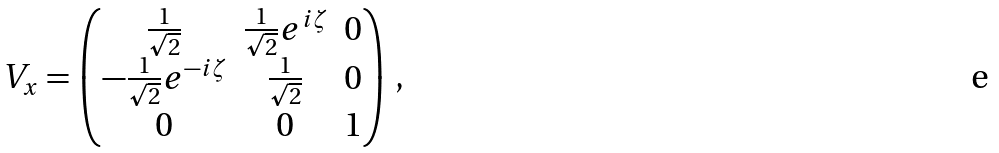Convert formula to latex. <formula><loc_0><loc_0><loc_500><loc_500>V _ { x } = \begin{pmatrix} \frac { 1 } { \sqrt { 2 } } & \frac { 1 } { \sqrt { 2 } } e ^ { i \zeta } & 0 \\ - \frac { 1 } { \sqrt { 2 } } e ^ { - i \zeta } & \frac { 1 } { \sqrt { 2 } } & 0 \\ 0 & 0 & 1 \end{pmatrix} \, ,</formula> 